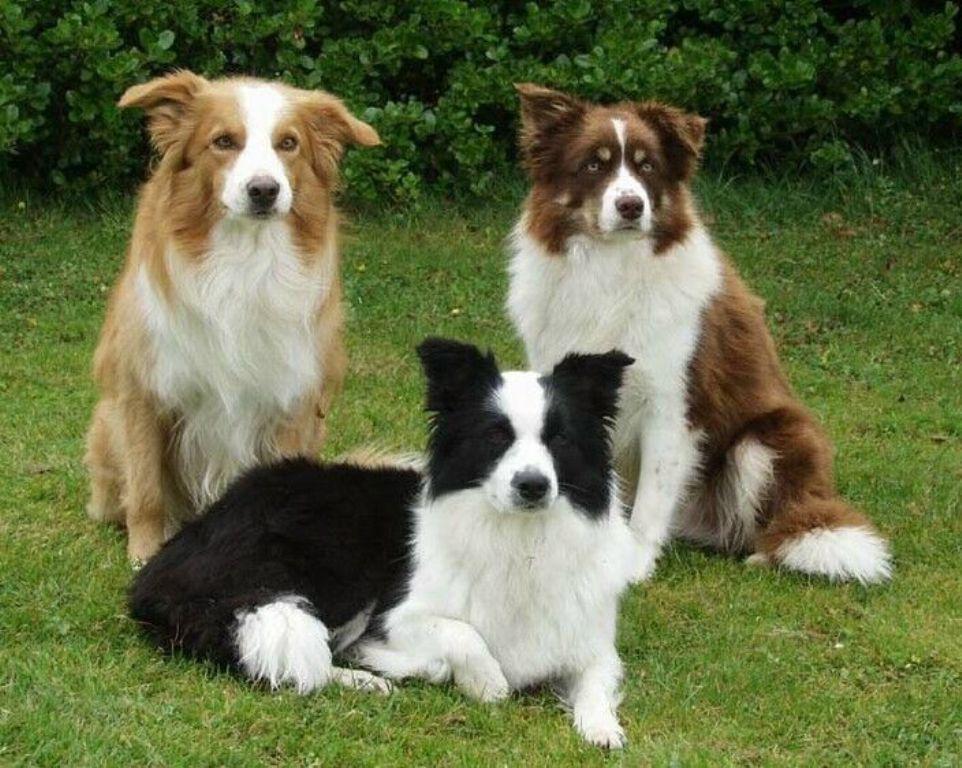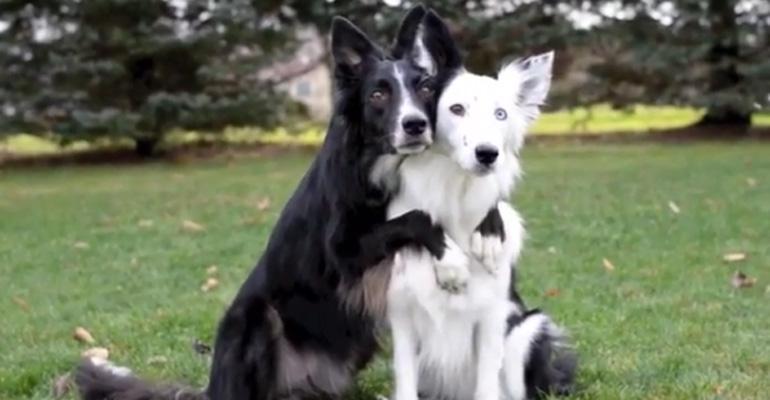The first image is the image on the left, the second image is the image on the right. For the images shown, is this caption "in the left image there is a do with the left ear up and the right ear down" true? Answer yes or no. Yes. The first image is the image on the left, the second image is the image on the right. Given the left and right images, does the statement "There are at least four dogs in total." hold true? Answer yes or no. Yes. 